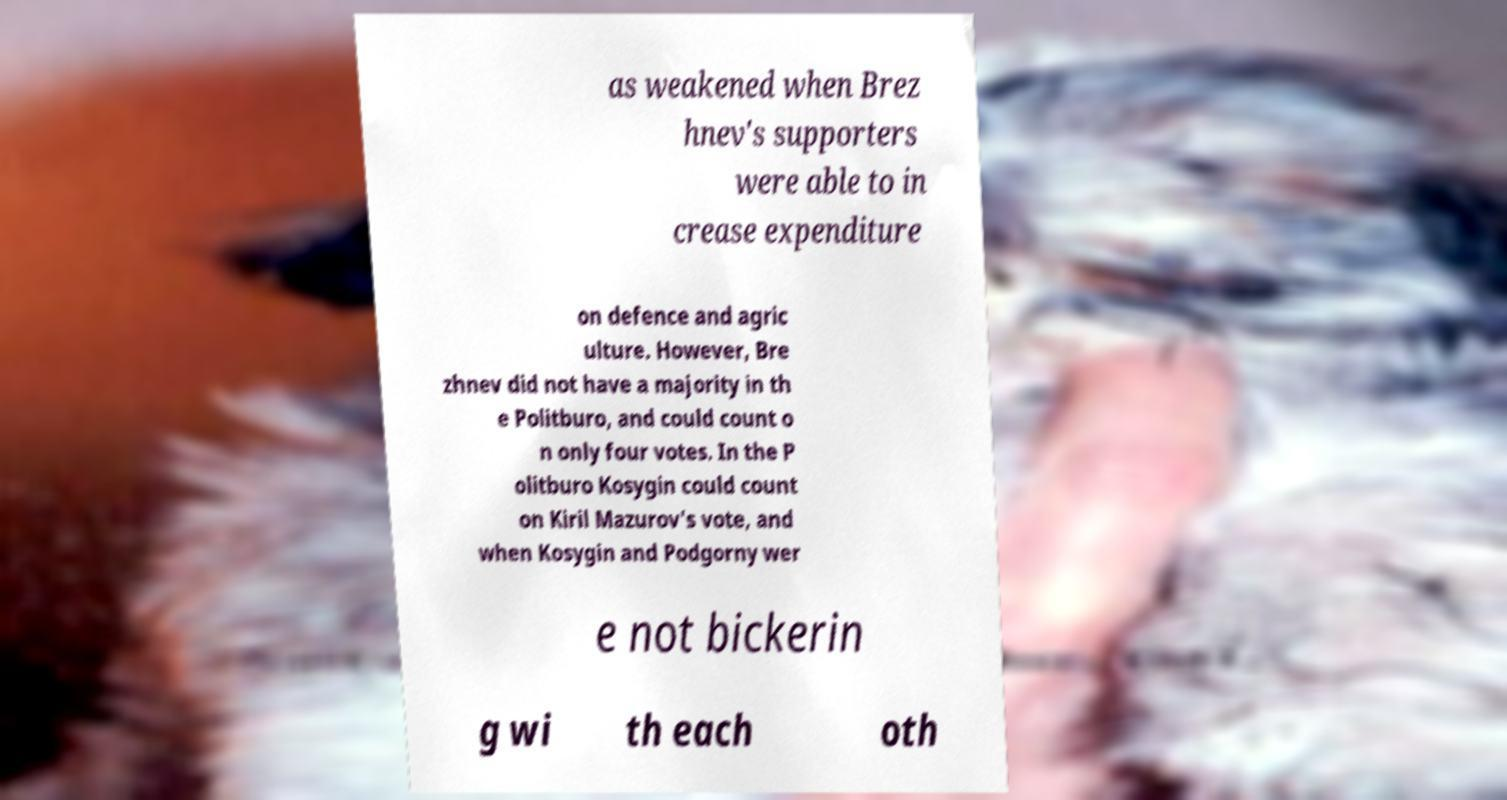I need the written content from this picture converted into text. Can you do that? as weakened when Brez hnev's supporters were able to in crease expenditure on defence and agric ulture. However, Bre zhnev did not have a majority in th e Politburo, and could count o n only four votes. In the P olitburo Kosygin could count on Kiril Mazurov's vote, and when Kosygin and Podgorny wer e not bickerin g wi th each oth 